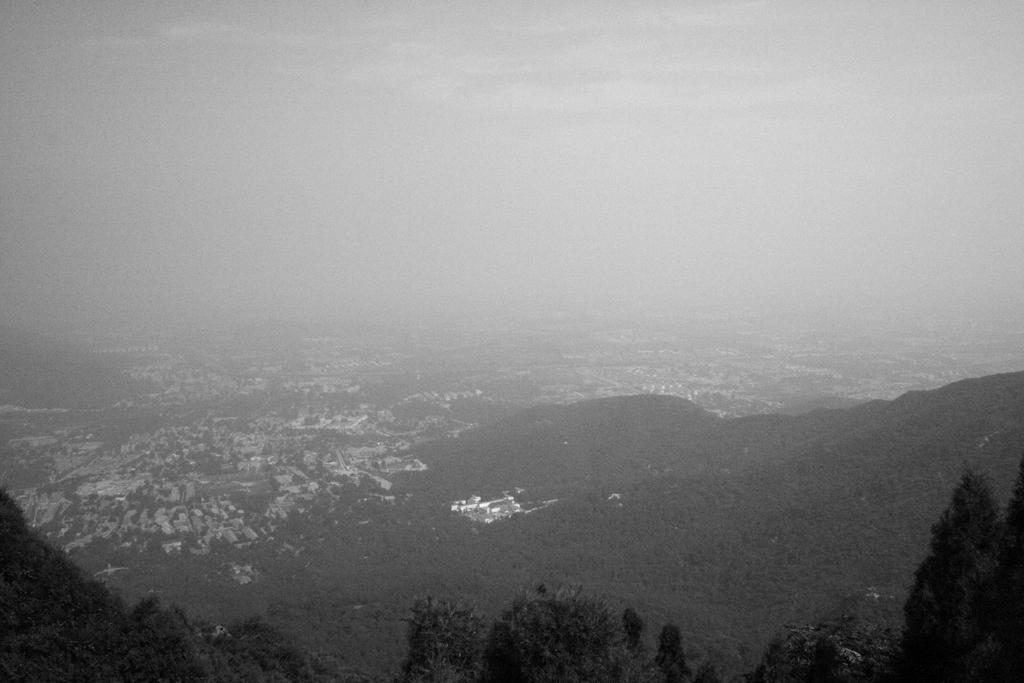What type of natural vegetation is present in the image? There are trees in the image. What type of man-made structures can be seen in the image? There are buildings in the image. What part of the natural environment is visible in the image? The sky is visible in the image. What is the color scheme of the image? The image is black and white in color. Can you see a kettle boiling water in the image? There is no kettle present in the image. What type of lipstick is the disgusting creature wearing in the image? There is no creature, disgusting or otherwise, wearing lipstick in the image. 